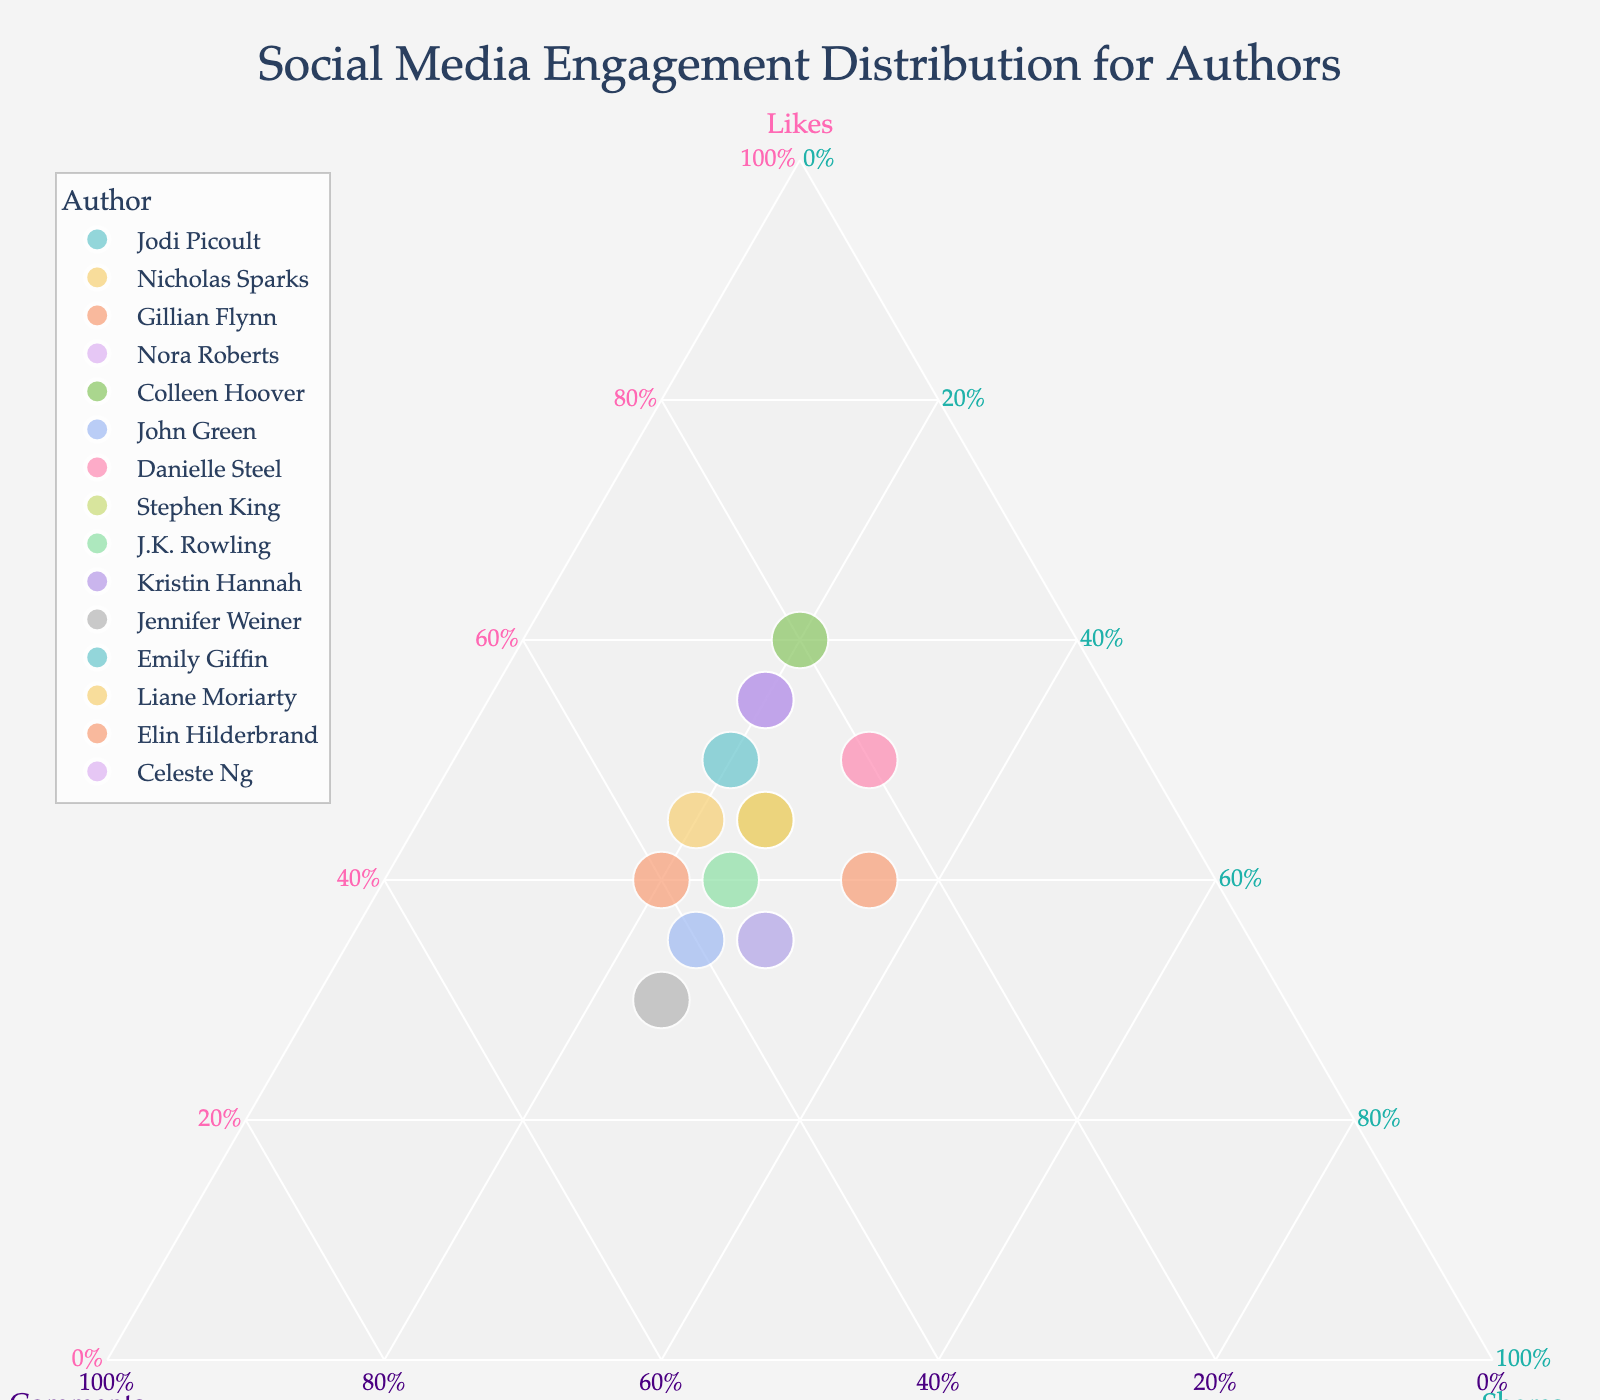How many data points are represented in the plot? There are 15 authors listed in the data, and each author corresponds to one point on the plot. You can count each of them individually.
Answer: 15 What are the ranges of the axes labeled 'Likes', 'Comments', and 'Shares'? The ternary plot has each axis ranging from 0% to 100%, representing the proportions of likes, comments, and shares. The percentages are shown on the axes.
Answer: 0% to 100% Which author has the highest proportion of likes? Colleen Hoover has the highest proportion of likes as her data point is closest to the vertex labeled 'Likes' on the ternary plot.
Answer: Colleen Hoover Who has a higher proportion of comments: John Green or J.K. Rowling? To determine which author has a higher proportion of comments, compare their positions relative to the 'Comments' axis. John Green's point is closer to the 'Comments' edge than J.K. Rowling's.
Answer: John Green Which two authors have identical proportions for shares? Celeste Ng and Emily Giffin both have their points located at the same position relative to the 'Shares' axis, indicating they share exactly 30% for shares.
Answer: Celeste Ng and Emily Giffin What's the average proportion of likes among all authors? First sum up all the proportions of likes: 50+45+40+55+60+35+50+45+40+55+30+35+45+40+35 = 600, then divide by the number of authors 600 / 15 = 40%.
Answer: 40% What is the difference in the proportion of likes between Jodi Picoult and Stephen King? Jodi Picoult has 50% likes, and Stephen King has 45% likes. The difference in likes is 50% - 45% = 5%.
Answer: 5% Who has equal proportions of comments and shares? Elin Hilderbrand has equal proportions of comments and shares, both at 20%, as seen from her data point's position on the ternary plot.
Answer: Elin Hilderbrand Who is positioned nearest to the center of the ternary plot? Nicholas Sparks is closest to the center of the ternary plot, indicating a more balanced distribution of likes, comments, and shares.
Answer: Nicholas Sparks 